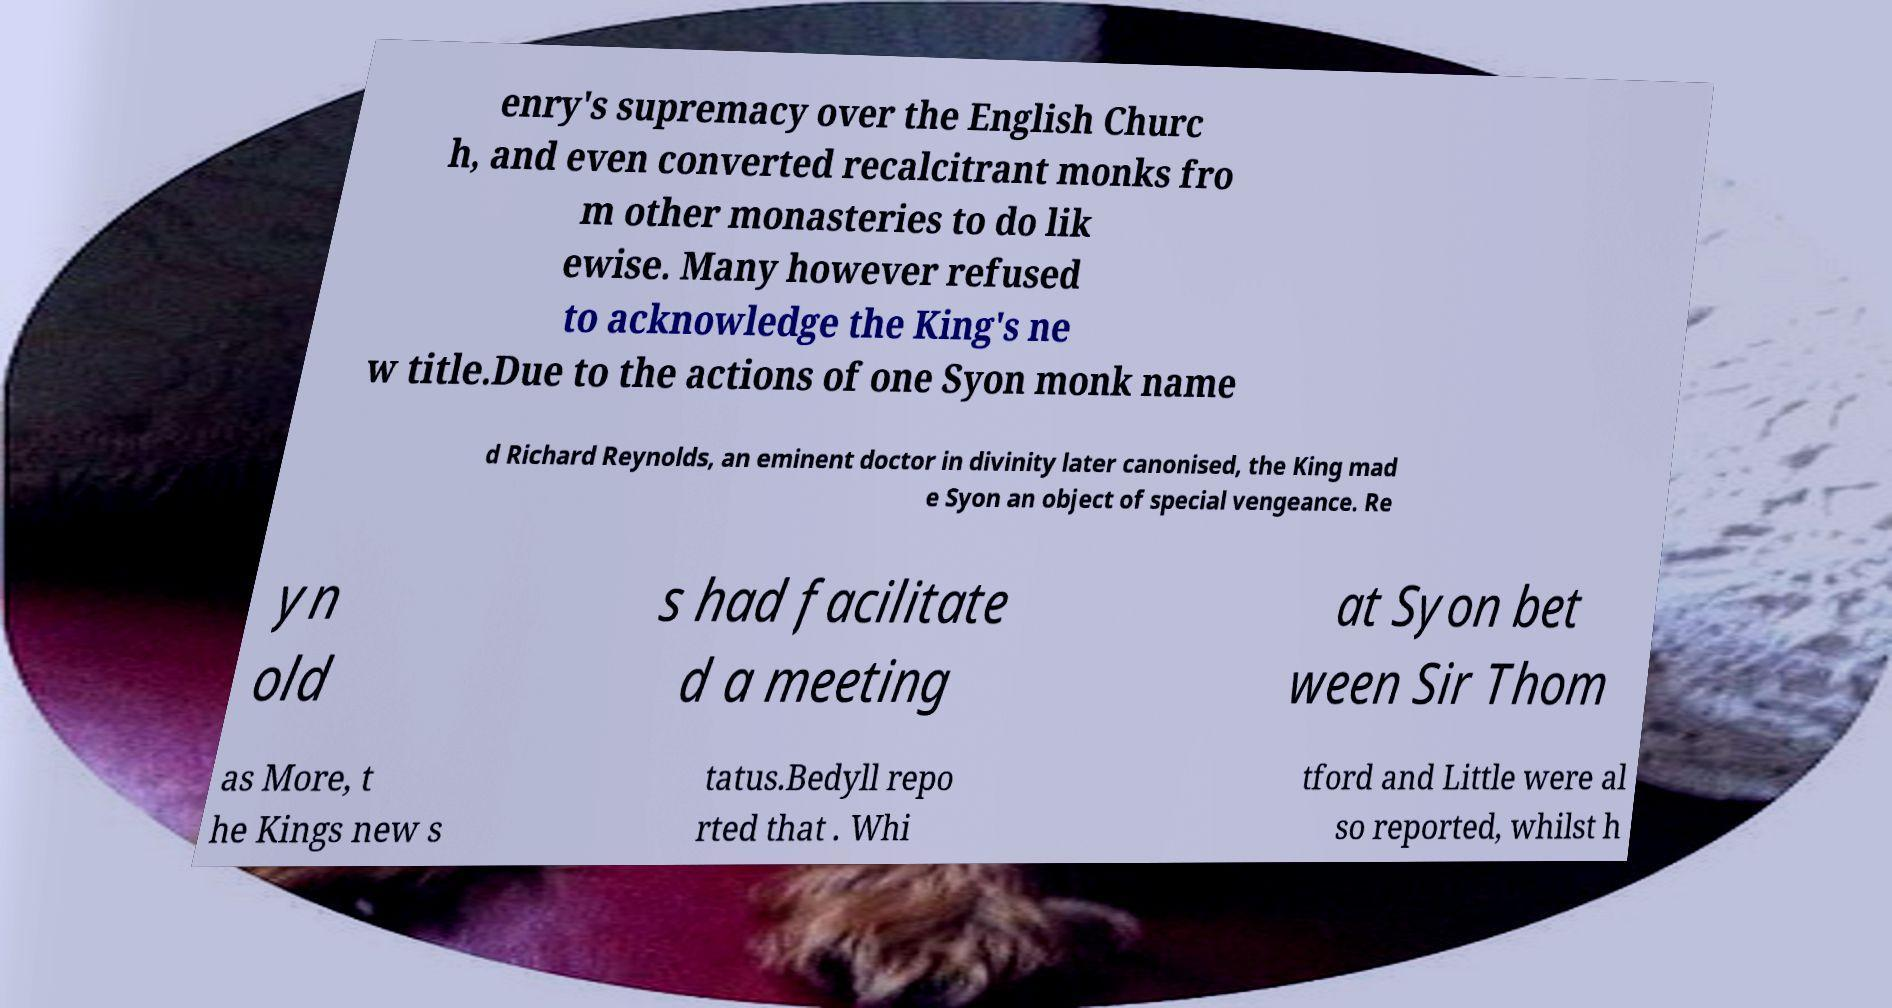There's text embedded in this image that I need extracted. Can you transcribe it verbatim? enry's supremacy over the English Churc h, and even converted recalcitrant monks fro m other monasteries to do lik ewise. Many however refused to acknowledge the King's ne w title.Due to the actions of one Syon monk name d Richard Reynolds, an eminent doctor in divinity later canonised, the King mad e Syon an object of special vengeance. Re yn old s had facilitate d a meeting at Syon bet ween Sir Thom as More, t he Kings new s tatus.Bedyll repo rted that . Whi tford and Little were al so reported, whilst h 